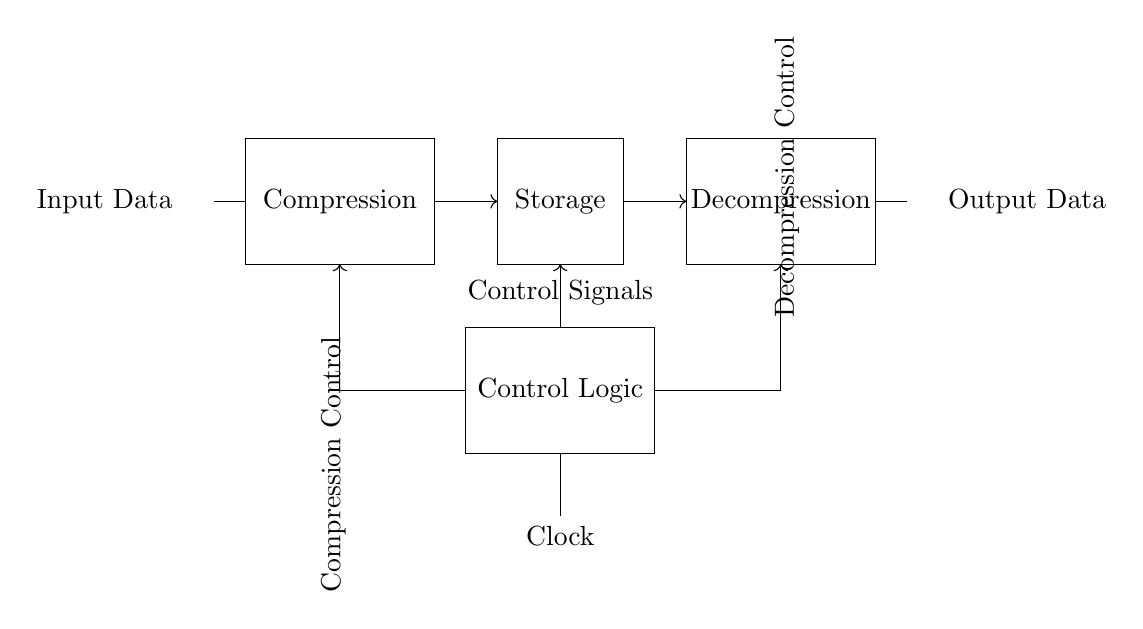What is the first block in the circuit? The first block in the circuit is labeled as "Compression". It is the component situated between the input data and the storage.
Answer: Compression What type of control signals are indicated in the diagram? The control signals are comprised of "Compression Control" and "Decompression Control." These controls direct the function of the corresponding compression and decompression blocks.
Answer: Compression Control, Decompression Control How many blocks are there in total in this circuit? The circuit comprises four distinct blocks: Input Data, Compression, Storage, and Decompression. Each block serves a specific function in the data compression and decompression process.
Answer: Four What does the storage block represent? The storage block signifies the section where the compressed data is held temporarily or permanently before being decompressed. It acts as a buffer for the processed information.
Answer: Storage What is the role of the clock in this circuit? The clock provides synchronization for the control logic and overall operation of the circuit. It ensures that the compression and decompression processes occur in a timely and coordinated manner, dictating when signals should be processed.
Answer: Synchronization What direction do the arrows on the connections indicate? The arrows signify the direction of data flow, indicating that data moves from the Compression block to the Storage block, then on to the Decompression block. This directional flow is essential for understanding the sequence of operations within the circuit.
Answer: Data flow direction 